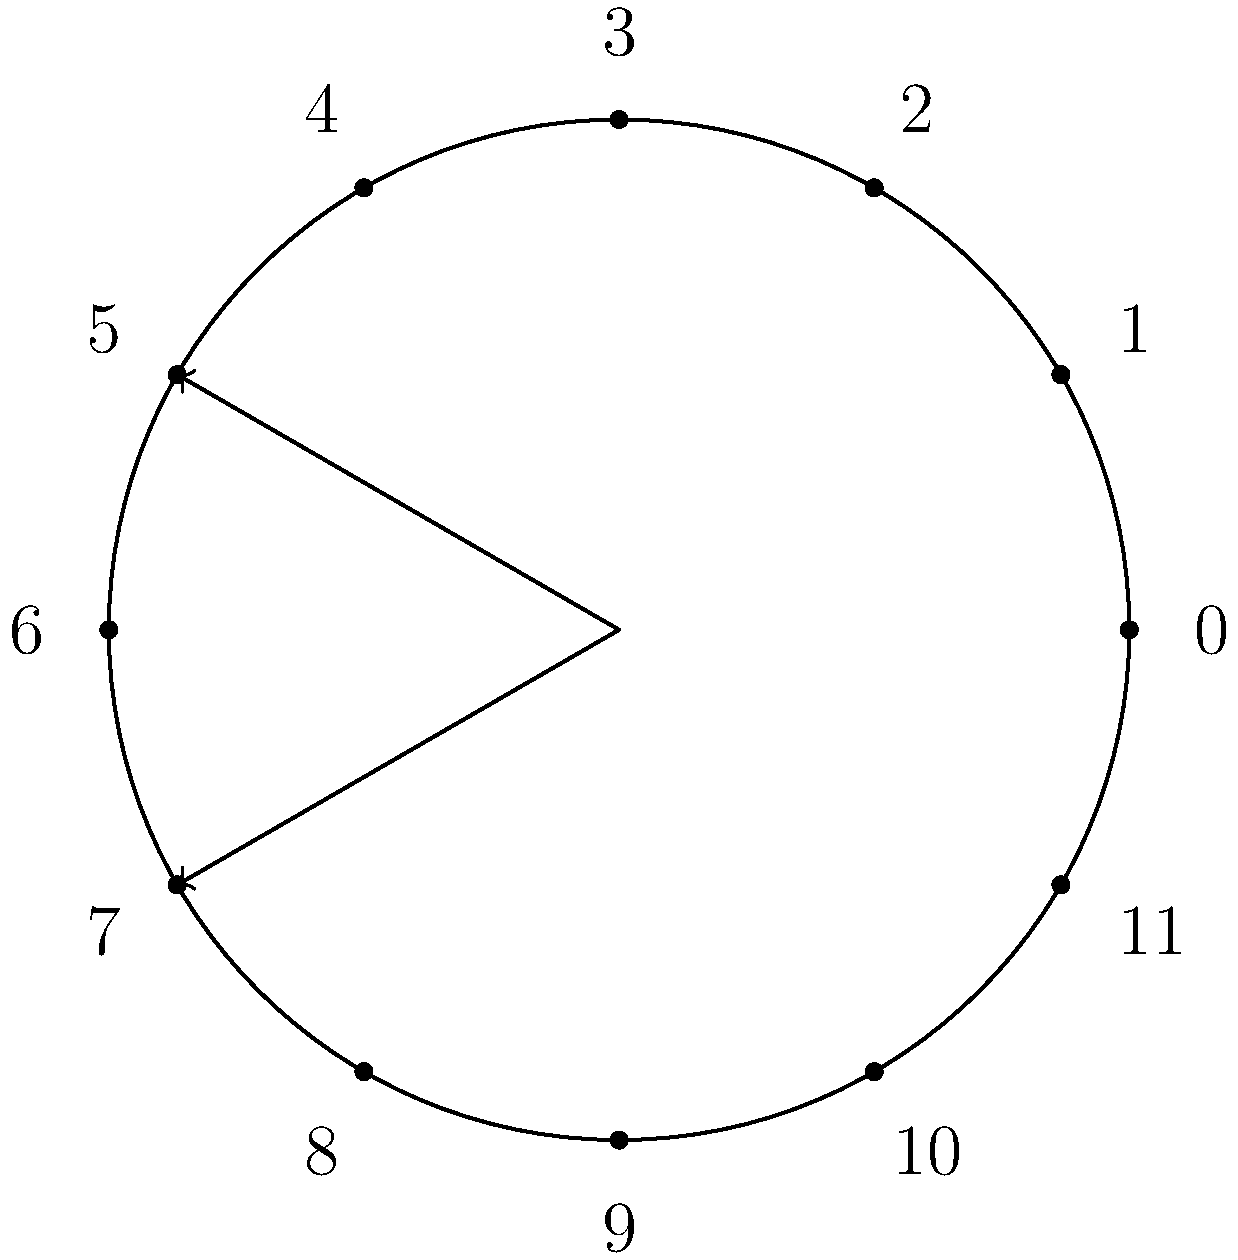In your engineering project, you're using a cyclic group to model a system with 12 states. The diagram shows a clock representation of this group. If the system starts at state 5 and undergoes a transformation equivalent to moving 7 steps clockwise, what is the resulting state? Express your answer as an element of $\mathbb{Z}_{12}$. Let's approach this step-by-step:

1) We're working in the cyclic group $\mathbb{Z}_{12}$, which is represented by the clock diagram with 12 positions (0 to 11).

2) The initial state is 5.

3) The transformation is equivalent to adding 7 to the current state.

4) In modular arithmetic, we perform the addition and then take the result modulo 12:

   $5 + 7 = 12$

5) However, in $\mathbb{Z}_{12}$, 12 is equivalent to 0 because:

   $12 \equiv 0 \pmod{12}$

6) Therefore, the resulting state after the transformation is 0.

This process is analogous to moving 7 steps clockwise from 5 on a clock, which would indeed bring us back to 0.
Answer: $0$ 